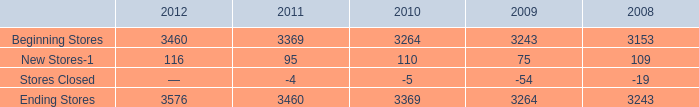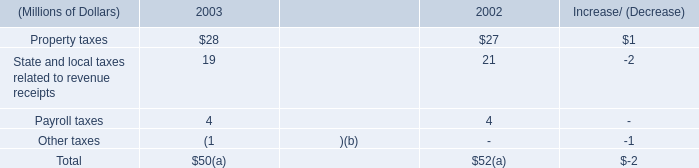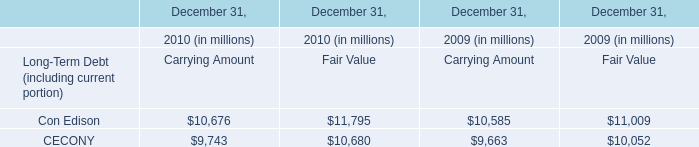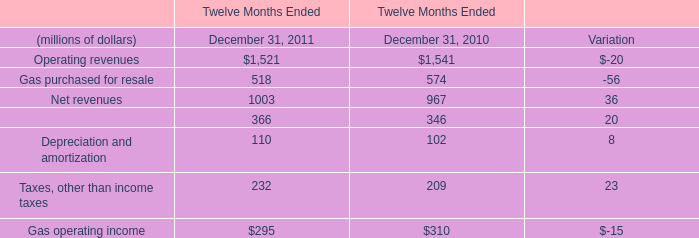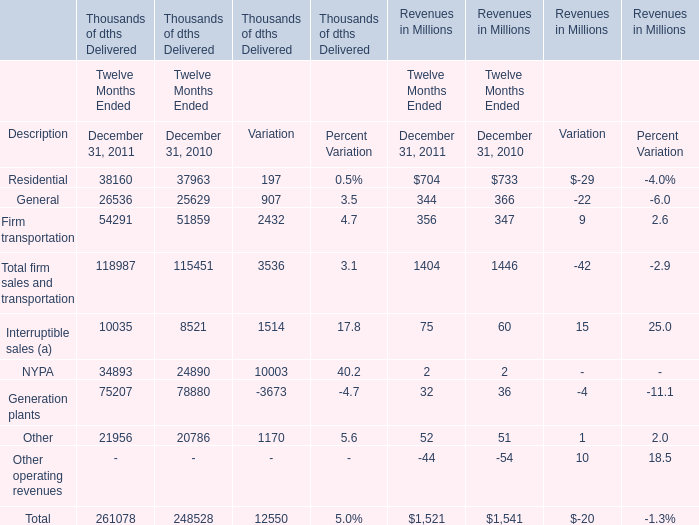what was the average annual creation of new stores for aap from 2008 to 2012? 
Computations: ((116 + 109) / 2)
Answer: 112.5. 